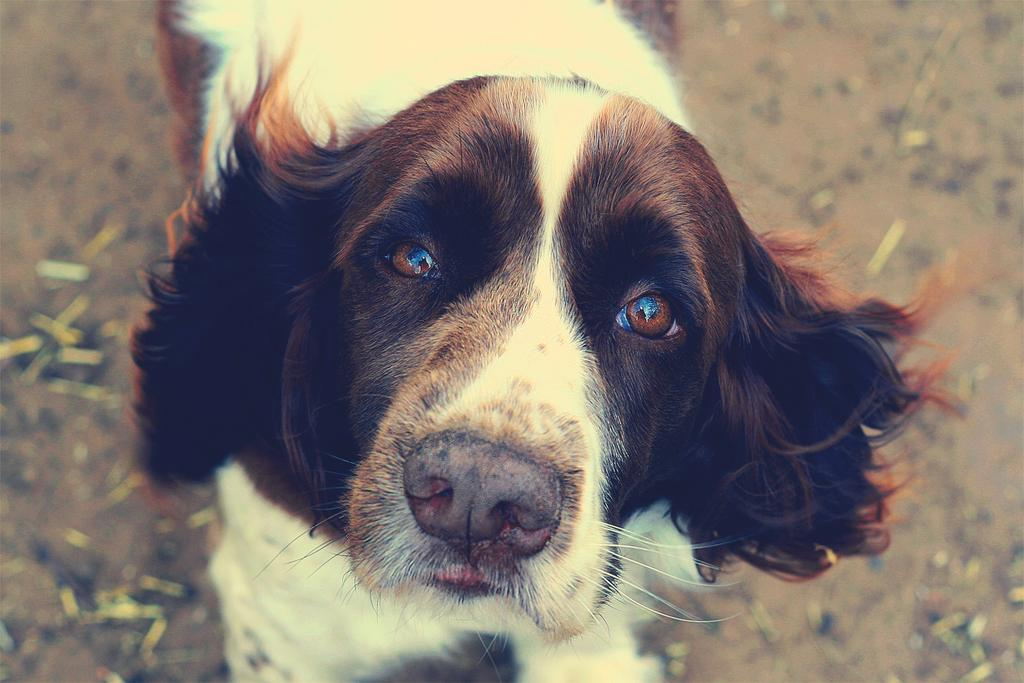What animal is present in the image? There is a dog in the picture. What colors can be seen on the dog? The dog is white and brown in color. What is the dog doing in the image? The dog is standing. What is the dog's focus in the image? The dog is looking into the camera. How is the background of the image depicted? There is a blurred background in the image. Can you tell me how many snails are crawling on the dog in the image? There are no snails present in the image; it features a dog standing and looking into the camera. What type of yak is visible in the background of the image? There is no yak present in the image; the background is blurred. 